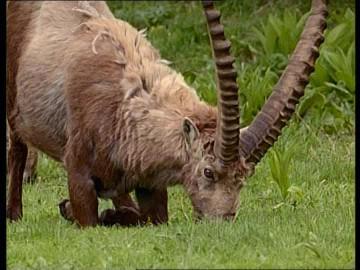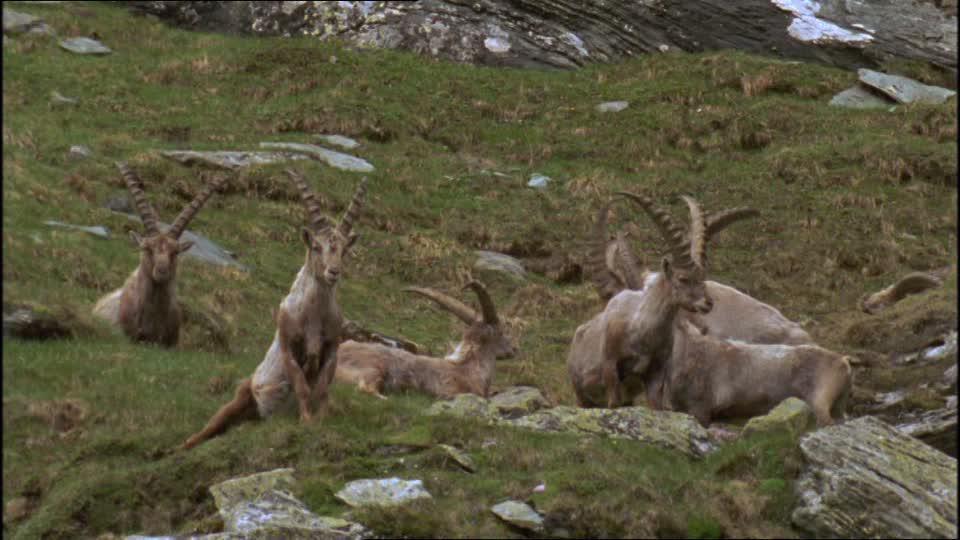The first image is the image on the left, the second image is the image on the right. Examine the images to the left and right. Is the description "Right image shows multiple horned animals grazing, with lowered heads." accurate? Answer yes or no. No. The first image is the image on the left, the second image is the image on the right. For the images shown, is this caption "There are no rocks near some of the animals." true? Answer yes or no. Yes. 